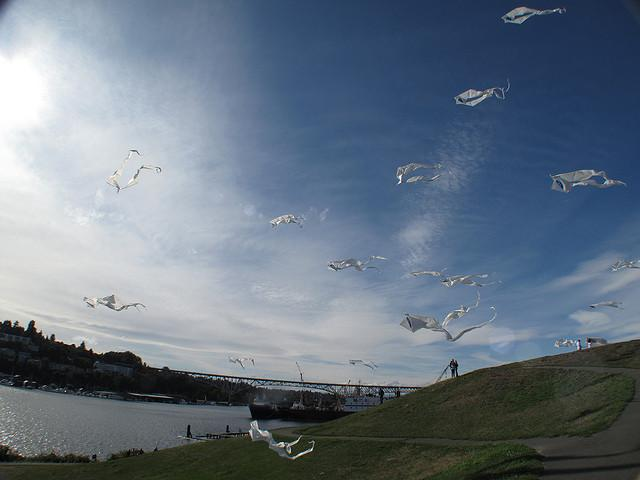How many kind of kite shapes available?

Choices:
A) eight
B) three
C) five
D) four eight 